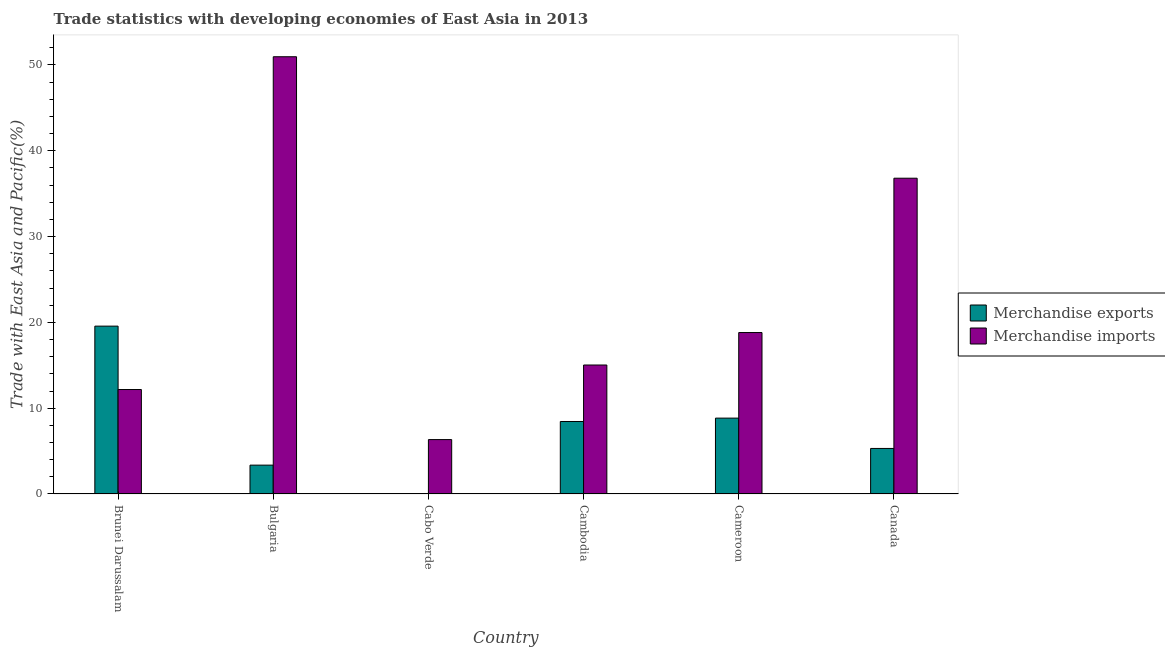How many groups of bars are there?
Ensure brevity in your answer.  6. Are the number of bars per tick equal to the number of legend labels?
Make the answer very short. Yes. Are the number of bars on each tick of the X-axis equal?
Keep it short and to the point. Yes. How many bars are there on the 2nd tick from the left?
Your response must be concise. 2. How many bars are there on the 6th tick from the right?
Make the answer very short. 2. What is the label of the 1st group of bars from the left?
Make the answer very short. Brunei Darussalam. In how many cases, is the number of bars for a given country not equal to the number of legend labels?
Offer a terse response. 0. What is the merchandise exports in Bulgaria?
Offer a terse response. 3.36. Across all countries, what is the maximum merchandise imports?
Your answer should be compact. 50.96. Across all countries, what is the minimum merchandise imports?
Keep it short and to the point. 6.34. In which country was the merchandise exports maximum?
Make the answer very short. Brunei Darussalam. In which country was the merchandise exports minimum?
Keep it short and to the point. Cabo Verde. What is the total merchandise imports in the graph?
Give a very brief answer. 140.12. What is the difference between the merchandise exports in Brunei Darussalam and that in Cabo Verde?
Offer a very short reply. 19.53. What is the difference between the merchandise imports in Cabo Verde and the merchandise exports in Cameroon?
Your response must be concise. -2.5. What is the average merchandise exports per country?
Your response must be concise. 7.59. What is the difference between the merchandise exports and merchandise imports in Bulgaria?
Your answer should be compact. -47.6. What is the ratio of the merchandise imports in Brunei Darussalam to that in Canada?
Offer a terse response. 0.33. Is the merchandise imports in Bulgaria less than that in Cabo Verde?
Keep it short and to the point. No. What is the difference between the highest and the second highest merchandise imports?
Provide a succinct answer. 14.16. What is the difference between the highest and the lowest merchandise imports?
Give a very brief answer. 44.62. In how many countries, is the merchandise imports greater than the average merchandise imports taken over all countries?
Ensure brevity in your answer.  2. Is the sum of the merchandise exports in Brunei Darussalam and Canada greater than the maximum merchandise imports across all countries?
Keep it short and to the point. No. What does the 2nd bar from the left in Brunei Darussalam represents?
Provide a succinct answer. Merchandise imports. What does the 1st bar from the right in Cambodia represents?
Give a very brief answer. Merchandise imports. What is the difference between two consecutive major ticks on the Y-axis?
Your answer should be very brief. 10. Are the values on the major ticks of Y-axis written in scientific E-notation?
Your answer should be very brief. No. Does the graph contain grids?
Give a very brief answer. No. Where does the legend appear in the graph?
Provide a short and direct response. Center right. How are the legend labels stacked?
Provide a succinct answer. Vertical. What is the title of the graph?
Keep it short and to the point. Trade statistics with developing economies of East Asia in 2013. Does "Passenger Transport Items" appear as one of the legend labels in the graph?
Your answer should be very brief. No. What is the label or title of the X-axis?
Your answer should be very brief. Country. What is the label or title of the Y-axis?
Offer a very short reply. Trade with East Asia and Pacific(%). What is the Trade with East Asia and Pacific(%) in Merchandise exports in Brunei Darussalam?
Your answer should be compact. 19.56. What is the Trade with East Asia and Pacific(%) in Merchandise imports in Brunei Darussalam?
Offer a very short reply. 12.17. What is the Trade with East Asia and Pacific(%) of Merchandise exports in Bulgaria?
Offer a terse response. 3.36. What is the Trade with East Asia and Pacific(%) of Merchandise imports in Bulgaria?
Provide a short and direct response. 50.96. What is the Trade with East Asia and Pacific(%) of Merchandise exports in Cabo Verde?
Your answer should be very brief. 0.03. What is the Trade with East Asia and Pacific(%) in Merchandise imports in Cabo Verde?
Offer a very short reply. 6.34. What is the Trade with East Asia and Pacific(%) in Merchandise exports in Cambodia?
Ensure brevity in your answer.  8.45. What is the Trade with East Asia and Pacific(%) in Merchandise imports in Cambodia?
Make the answer very short. 15.03. What is the Trade with East Asia and Pacific(%) in Merchandise exports in Cameroon?
Your answer should be compact. 8.84. What is the Trade with East Asia and Pacific(%) of Merchandise imports in Cameroon?
Provide a succinct answer. 18.82. What is the Trade with East Asia and Pacific(%) in Merchandise exports in Canada?
Provide a succinct answer. 5.31. What is the Trade with East Asia and Pacific(%) in Merchandise imports in Canada?
Keep it short and to the point. 36.8. Across all countries, what is the maximum Trade with East Asia and Pacific(%) of Merchandise exports?
Your answer should be compact. 19.56. Across all countries, what is the maximum Trade with East Asia and Pacific(%) in Merchandise imports?
Your response must be concise. 50.96. Across all countries, what is the minimum Trade with East Asia and Pacific(%) in Merchandise exports?
Your answer should be compact. 0.03. Across all countries, what is the minimum Trade with East Asia and Pacific(%) of Merchandise imports?
Keep it short and to the point. 6.34. What is the total Trade with East Asia and Pacific(%) of Merchandise exports in the graph?
Provide a short and direct response. 45.55. What is the total Trade with East Asia and Pacific(%) in Merchandise imports in the graph?
Your response must be concise. 140.12. What is the difference between the Trade with East Asia and Pacific(%) in Merchandise exports in Brunei Darussalam and that in Bulgaria?
Make the answer very short. 16.2. What is the difference between the Trade with East Asia and Pacific(%) of Merchandise imports in Brunei Darussalam and that in Bulgaria?
Offer a very short reply. -38.79. What is the difference between the Trade with East Asia and Pacific(%) of Merchandise exports in Brunei Darussalam and that in Cabo Verde?
Your response must be concise. 19.53. What is the difference between the Trade with East Asia and Pacific(%) of Merchandise imports in Brunei Darussalam and that in Cabo Verde?
Your answer should be compact. 5.84. What is the difference between the Trade with East Asia and Pacific(%) of Merchandise exports in Brunei Darussalam and that in Cambodia?
Make the answer very short. 11.11. What is the difference between the Trade with East Asia and Pacific(%) in Merchandise imports in Brunei Darussalam and that in Cambodia?
Your answer should be compact. -2.86. What is the difference between the Trade with East Asia and Pacific(%) in Merchandise exports in Brunei Darussalam and that in Cameroon?
Keep it short and to the point. 10.72. What is the difference between the Trade with East Asia and Pacific(%) of Merchandise imports in Brunei Darussalam and that in Cameroon?
Ensure brevity in your answer.  -6.64. What is the difference between the Trade with East Asia and Pacific(%) in Merchandise exports in Brunei Darussalam and that in Canada?
Keep it short and to the point. 14.26. What is the difference between the Trade with East Asia and Pacific(%) of Merchandise imports in Brunei Darussalam and that in Canada?
Provide a succinct answer. -24.63. What is the difference between the Trade with East Asia and Pacific(%) of Merchandise exports in Bulgaria and that in Cabo Verde?
Your answer should be very brief. 3.33. What is the difference between the Trade with East Asia and Pacific(%) of Merchandise imports in Bulgaria and that in Cabo Verde?
Provide a succinct answer. 44.62. What is the difference between the Trade with East Asia and Pacific(%) in Merchandise exports in Bulgaria and that in Cambodia?
Your answer should be compact. -5.09. What is the difference between the Trade with East Asia and Pacific(%) of Merchandise imports in Bulgaria and that in Cambodia?
Your answer should be compact. 35.93. What is the difference between the Trade with East Asia and Pacific(%) of Merchandise exports in Bulgaria and that in Cameroon?
Make the answer very short. -5.48. What is the difference between the Trade with East Asia and Pacific(%) in Merchandise imports in Bulgaria and that in Cameroon?
Make the answer very short. 32.15. What is the difference between the Trade with East Asia and Pacific(%) of Merchandise exports in Bulgaria and that in Canada?
Offer a very short reply. -1.95. What is the difference between the Trade with East Asia and Pacific(%) of Merchandise imports in Bulgaria and that in Canada?
Make the answer very short. 14.16. What is the difference between the Trade with East Asia and Pacific(%) in Merchandise exports in Cabo Verde and that in Cambodia?
Your response must be concise. -8.42. What is the difference between the Trade with East Asia and Pacific(%) in Merchandise imports in Cabo Verde and that in Cambodia?
Make the answer very short. -8.69. What is the difference between the Trade with East Asia and Pacific(%) of Merchandise exports in Cabo Verde and that in Cameroon?
Your response must be concise. -8.81. What is the difference between the Trade with East Asia and Pacific(%) of Merchandise imports in Cabo Verde and that in Cameroon?
Your response must be concise. -12.48. What is the difference between the Trade with East Asia and Pacific(%) of Merchandise exports in Cabo Verde and that in Canada?
Ensure brevity in your answer.  -5.28. What is the difference between the Trade with East Asia and Pacific(%) of Merchandise imports in Cabo Verde and that in Canada?
Your response must be concise. -30.47. What is the difference between the Trade with East Asia and Pacific(%) in Merchandise exports in Cambodia and that in Cameroon?
Ensure brevity in your answer.  -0.39. What is the difference between the Trade with East Asia and Pacific(%) in Merchandise imports in Cambodia and that in Cameroon?
Give a very brief answer. -3.79. What is the difference between the Trade with East Asia and Pacific(%) in Merchandise exports in Cambodia and that in Canada?
Ensure brevity in your answer.  3.14. What is the difference between the Trade with East Asia and Pacific(%) of Merchandise imports in Cambodia and that in Canada?
Make the answer very short. -21.77. What is the difference between the Trade with East Asia and Pacific(%) of Merchandise exports in Cameroon and that in Canada?
Keep it short and to the point. 3.53. What is the difference between the Trade with East Asia and Pacific(%) in Merchandise imports in Cameroon and that in Canada?
Ensure brevity in your answer.  -17.99. What is the difference between the Trade with East Asia and Pacific(%) of Merchandise exports in Brunei Darussalam and the Trade with East Asia and Pacific(%) of Merchandise imports in Bulgaria?
Offer a terse response. -31.4. What is the difference between the Trade with East Asia and Pacific(%) in Merchandise exports in Brunei Darussalam and the Trade with East Asia and Pacific(%) in Merchandise imports in Cabo Verde?
Your answer should be compact. 13.22. What is the difference between the Trade with East Asia and Pacific(%) in Merchandise exports in Brunei Darussalam and the Trade with East Asia and Pacific(%) in Merchandise imports in Cambodia?
Provide a short and direct response. 4.53. What is the difference between the Trade with East Asia and Pacific(%) of Merchandise exports in Brunei Darussalam and the Trade with East Asia and Pacific(%) of Merchandise imports in Cameroon?
Your answer should be compact. 0.75. What is the difference between the Trade with East Asia and Pacific(%) in Merchandise exports in Brunei Darussalam and the Trade with East Asia and Pacific(%) in Merchandise imports in Canada?
Your answer should be compact. -17.24. What is the difference between the Trade with East Asia and Pacific(%) of Merchandise exports in Bulgaria and the Trade with East Asia and Pacific(%) of Merchandise imports in Cabo Verde?
Make the answer very short. -2.98. What is the difference between the Trade with East Asia and Pacific(%) of Merchandise exports in Bulgaria and the Trade with East Asia and Pacific(%) of Merchandise imports in Cambodia?
Provide a short and direct response. -11.67. What is the difference between the Trade with East Asia and Pacific(%) in Merchandise exports in Bulgaria and the Trade with East Asia and Pacific(%) in Merchandise imports in Cameroon?
Offer a very short reply. -15.45. What is the difference between the Trade with East Asia and Pacific(%) of Merchandise exports in Bulgaria and the Trade with East Asia and Pacific(%) of Merchandise imports in Canada?
Provide a succinct answer. -33.44. What is the difference between the Trade with East Asia and Pacific(%) of Merchandise exports in Cabo Verde and the Trade with East Asia and Pacific(%) of Merchandise imports in Cambodia?
Keep it short and to the point. -15. What is the difference between the Trade with East Asia and Pacific(%) of Merchandise exports in Cabo Verde and the Trade with East Asia and Pacific(%) of Merchandise imports in Cameroon?
Keep it short and to the point. -18.78. What is the difference between the Trade with East Asia and Pacific(%) of Merchandise exports in Cabo Verde and the Trade with East Asia and Pacific(%) of Merchandise imports in Canada?
Keep it short and to the point. -36.77. What is the difference between the Trade with East Asia and Pacific(%) of Merchandise exports in Cambodia and the Trade with East Asia and Pacific(%) of Merchandise imports in Cameroon?
Keep it short and to the point. -10.37. What is the difference between the Trade with East Asia and Pacific(%) in Merchandise exports in Cambodia and the Trade with East Asia and Pacific(%) in Merchandise imports in Canada?
Offer a very short reply. -28.36. What is the difference between the Trade with East Asia and Pacific(%) in Merchandise exports in Cameroon and the Trade with East Asia and Pacific(%) in Merchandise imports in Canada?
Ensure brevity in your answer.  -27.96. What is the average Trade with East Asia and Pacific(%) of Merchandise exports per country?
Make the answer very short. 7.59. What is the average Trade with East Asia and Pacific(%) in Merchandise imports per country?
Keep it short and to the point. 23.35. What is the difference between the Trade with East Asia and Pacific(%) of Merchandise exports and Trade with East Asia and Pacific(%) of Merchandise imports in Brunei Darussalam?
Offer a terse response. 7.39. What is the difference between the Trade with East Asia and Pacific(%) of Merchandise exports and Trade with East Asia and Pacific(%) of Merchandise imports in Bulgaria?
Your answer should be compact. -47.6. What is the difference between the Trade with East Asia and Pacific(%) of Merchandise exports and Trade with East Asia and Pacific(%) of Merchandise imports in Cabo Verde?
Offer a very short reply. -6.31. What is the difference between the Trade with East Asia and Pacific(%) of Merchandise exports and Trade with East Asia and Pacific(%) of Merchandise imports in Cambodia?
Your answer should be compact. -6.58. What is the difference between the Trade with East Asia and Pacific(%) of Merchandise exports and Trade with East Asia and Pacific(%) of Merchandise imports in Cameroon?
Offer a very short reply. -9.97. What is the difference between the Trade with East Asia and Pacific(%) in Merchandise exports and Trade with East Asia and Pacific(%) in Merchandise imports in Canada?
Offer a very short reply. -31.5. What is the ratio of the Trade with East Asia and Pacific(%) of Merchandise exports in Brunei Darussalam to that in Bulgaria?
Give a very brief answer. 5.82. What is the ratio of the Trade with East Asia and Pacific(%) in Merchandise imports in Brunei Darussalam to that in Bulgaria?
Provide a short and direct response. 0.24. What is the ratio of the Trade with East Asia and Pacific(%) in Merchandise exports in Brunei Darussalam to that in Cabo Verde?
Give a very brief answer. 622.48. What is the ratio of the Trade with East Asia and Pacific(%) in Merchandise imports in Brunei Darussalam to that in Cabo Verde?
Your response must be concise. 1.92. What is the ratio of the Trade with East Asia and Pacific(%) in Merchandise exports in Brunei Darussalam to that in Cambodia?
Provide a short and direct response. 2.32. What is the ratio of the Trade with East Asia and Pacific(%) in Merchandise imports in Brunei Darussalam to that in Cambodia?
Keep it short and to the point. 0.81. What is the ratio of the Trade with East Asia and Pacific(%) of Merchandise exports in Brunei Darussalam to that in Cameroon?
Your response must be concise. 2.21. What is the ratio of the Trade with East Asia and Pacific(%) of Merchandise imports in Brunei Darussalam to that in Cameroon?
Your response must be concise. 0.65. What is the ratio of the Trade with East Asia and Pacific(%) in Merchandise exports in Brunei Darussalam to that in Canada?
Offer a very short reply. 3.69. What is the ratio of the Trade with East Asia and Pacific(%) of Merchandise imports in Brunei Darussalam to that in Canada?
Offer a terse response. 0.33. What is the ratio of the Trade with East Asia and Pacific(%) of Merchandise exports in Bulgaria to that in Cabo Verde?
Offer a very short reply. 106.94. What is the ratio of the Trade with East Asia and Pacific(%) in Merchandise imports in Bulgaria to that in Cabo Verde?
Ensure brevity in your answer.  8.04. What is the ratio of the Trade with East Asia and Pacific(%) of Merchandise exports in Bulgaria to that in Cambodia?
Your answer should be compact. 0.4. What is the ratio of the Trade with East Asia and Pacific(%) of Merchandise imports in Bulgaria to that in Cambodia?
Offer a terse response. 3.39. What is the ratio of the Trade with East Asia and Pacific(%) of Merchandise exports in Bulgaria to that in Cameroon?
Your answer should be very brief. 0.38. What is the ratio of the Trade with East Asia and Pacific(%) of Merchandise imports in Bulgaria to that in Cameroon?
Give a very brief answer. 2.71. What is the ratio of the Trade with East Asia and Pacific(%) in Merchandise exports in Bulgaria to that in Canada?
Offer a terse response. 0.63. What is the ratio of the Trade with East Asia and Pacific(%) in Merchandise imports in Bulgaria to that in Canada?
Ensure brevity in your answer.  1.38. What is the ratio of the Trade with East Asia and Pacific(%) in Merchandise exports in Cabo Verde to that in Cambodia?
Your answer should be very brief. 0. What is the ratio of the Trade with East Asia and Pacific(%) in Merchandise imports in Cabo Verde to that in Cambodia?
Your response must be concise. 0.42. What is the ratio of the Trade with East Asia and Pacific(%) of Merchandise exports in Cabo Verde to that in Cameroon?
Make the answer very short. 0. What is the ratio of the Trade with East Asia and Pacific(%) in Merchandise imports in Cabo Verde to that in Cameroon?
Your response must be concise. 0.34. What is the ratio of the Trade with East Asia and Pacific(%) in Merchandise exports in Cabo Verde to that in Canada?
Your answer should be compact. 0.01. What is the ratio of the Trade with East Asia and Pacific(%) of Merchandise imports in Cabo Verde to that in Canada?
Your answer should be very brief. 0.17. What is the ratio of the Trade with East Asia and Pacific(%) of Merchandise exports in Cambodia to that in Cameroon?
Provide a succinct answer. 0.96. What is the ratio of the Trade with East Asia and Pacific(%) of Merchandise imports in Cambodia to that in Cameroon?
Your response must be concise. 0.8. What is the ratio of the Trade with East Asia and Pacific(%) in Merchandise exports in Cambodia to that in Canada?
Make the answer very short. 1.59. What is the ratio of the Trade with East Asia and Pacific(%) of Merchandise imports in Cambodia to that in Canada?
Provide a short and direct response. 0.41. What is the ratio of the Trade with East Asia and Pacific(%) of Merchandise exports in Cameroon to that in Canada?
Ensure brevity in your answer.  1.67. What is the ratio of the Trade with East Asia and Pacific(%) of Merchandise imports in Cameroon to that in Canada?
Ensure brevity in your answer.  0.51. What is the difference between the highest and the second highest Trade with East Asia and Pacific(%) of Merchandise exports?
Make the answer very short. 10.72. What is the difference between the highest and the second highest Trade with East Asia and Pacific(%) of Merchandise imports?
Your response must be concise. 14.16. What is the difference between the highest and the lowest Trade with East Asia and Pacific(%) of Merchandise exports?
Keep it short and to the point. 19.53. What is the difference between the highest and the lowest Trade with East Asia and Pacific(%) in Merchandise imports?
Make the answer very short. 44.62. 